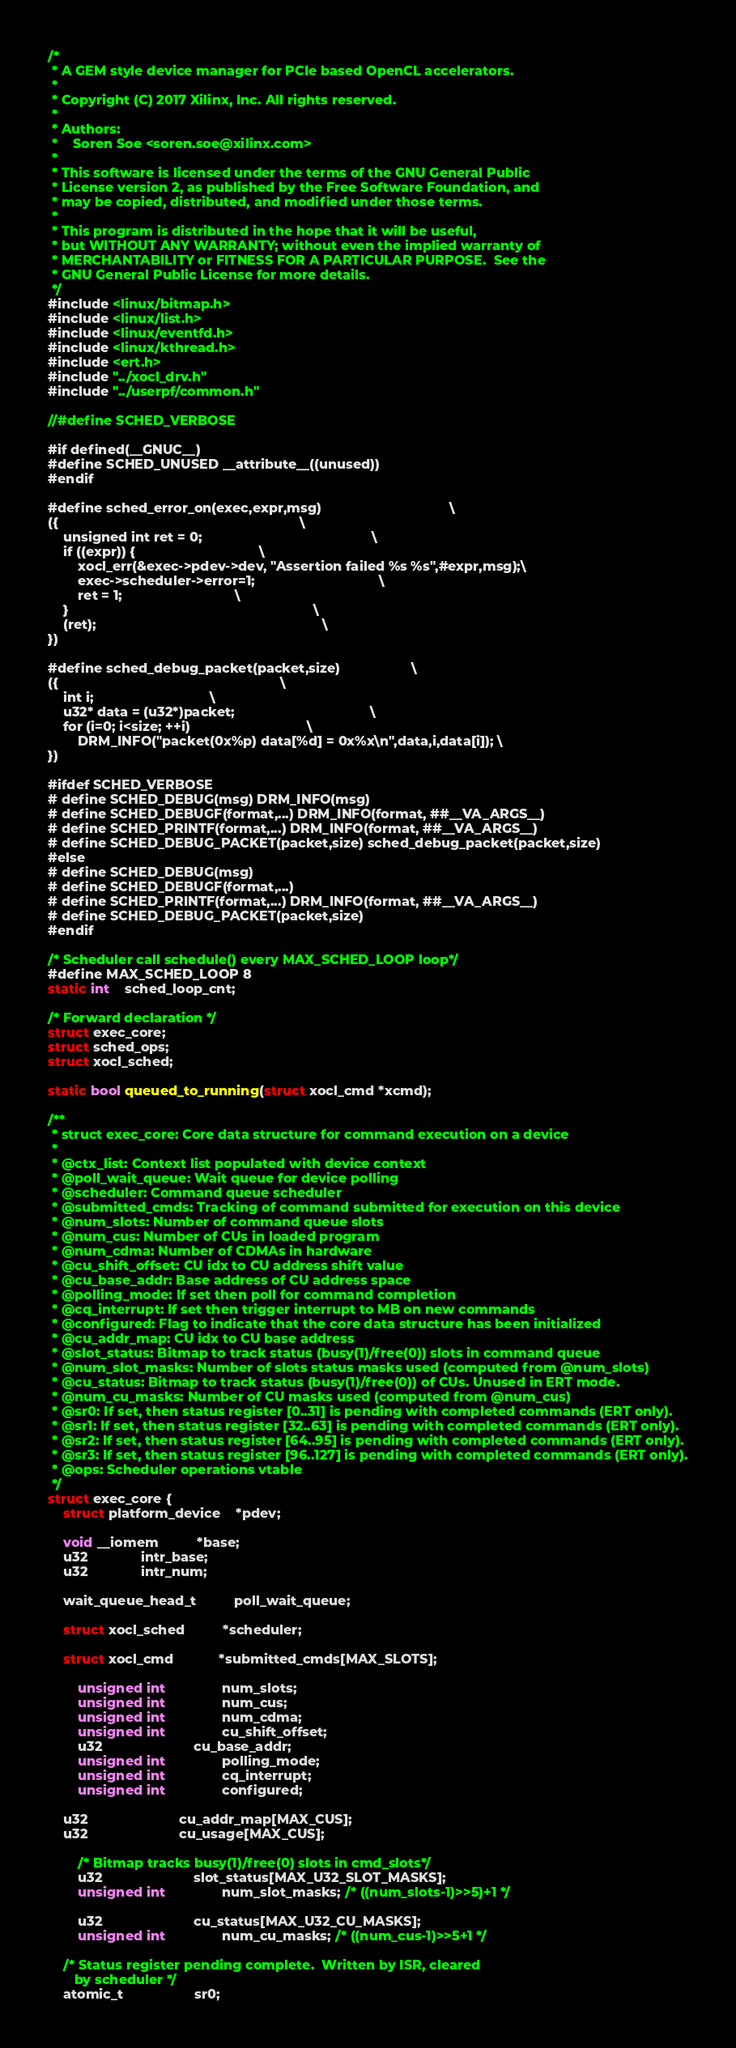Convert code to text. <code><loc_0><loc_0><loc_500><loc_500><_C_>/*
 * A GEM style device manager for PCIe based OpenCL accelerators.
 *
 * Copyright (C) 2017 Xilinx, Inc. All rights reserved.
 *
 * Authors:
 *    Soren Soe <soren.soe@xilinx.com>
 *
 * This software is licensed under the terms of the GNU General Public
 * License version 2, as published by the Free Software Foundation, and
 * may be copied, distributed, and modified under those terms.
 *
 * This program is distributed in the hope that it will be useful,
 * but WITHOUT ANY WARRANTY; without even the implied warranty of
 * MERCHANTABILITY or FITNESS FOR A PARTICULAR PURPOSE.  See the
 * GNU General Public License for more details.
 */
#include <linux/bitmap.h>
#include <linux/list.h>
#include <linux/eventfd.h>
#include <linux/kthread.h>
#include <ert.h>
#include "../xocl_drv.h"
#include "../userpf/common.h"

//#define SCHED_VERBOSE

#if defined(__GNUC__)
#define SCHED_UNUSED __attribute__((unused))
#endif

#define sched_error_on(exec,expr,msg)		                          \
({		                                                          \
	unsigned int ret = 0;                                             \
	if ((expr)) {						          \
		xocl_err(&exec->pdev->dev, "Assertion failed %s %s",#expr,msg);\
		exec->scheduler->error=1;                                 \
		ret = 1; 					          \
	}                                                                 \
	(ret);                                                            \
})

#define sched_debug_packet(packet,size)				     \
({		                                                     \
	int i;							     \
	u32* data = (u32*)packet;                                    \
	for (i=0; i<size; ++i)			    	             \
		DRM_INFO("packet(0x%p) data[%d] = 0x%x\n",data,i,data[i]); \
})

#ifdef SCHED_VERBOSE
# define SCHED_DEBUG(msg) DRM_INFO(msg)
# define SCHED_DEBUGF(format,...) DRM_INFO(format, ##__VA_ARGS__)
# define SCHED_PRINTF(format,...) DRM_INFO(format, ##__VA_ARGS__)
# define SCHED_DEBUG_PACKET(packet,size) sched_debug_packet(packet,size)
#else
# define SCHED_DEBUG(msg)
# define SCHED_DEBUGF(format,...)
# define SCHED_PRINTF(format,...) DRM_INFO(format, ##__VA_ARGS__)
# define SCHED_DEBUG_PACKET(packet,size)
#endif

/* Scheduler call schedule() every MAX_SCHED_LOOP loop*/
#define MAX_SCHED_LOOP 8
static int    sched_loop_cnt;

/* Forward declaration */
struct exec_core;
struct sched_ops;
struct xocl_sched;

static bool queued_to_running(struct xocl_cmd *xcmd);

/**
 * struct exec_core: Core data structure for command execution on a device
 *
 * @ctx_list: Context list populated with device context
 * @poll_wait_queue: Wait queue for device polling
 * @scheduler: Command queue scheduler
 * @submitted_cmds: Tracking of command submitted for execution on this device
 * @num_slots: Number of command queue slots
 * @num_cus: Number of CUs in loaded program
 * @num_cdma: Number of CDMAs in hardware
 * @cu_shift_offset: CU idx to CU address shift value
 * @cu_base_addr: Base address of CU address space
 * @polling_mode: If set then poll for command completion
 * @cq_interrupt: If set then trigger interrupt to MB on new commands
 * @configured: Flag to indicate that the core data structure has been initialized
 * @cu_addr_map: CU idx to CU base address
 * @slot_status: Bitmap to track status (busy(1)/free(0)) slots in command queue
 * @num_slot_masks: Number of slots status masks used (computed from @num_slots)
 * @cu_status: Bitmap to track status (busy(1)/free(0)) of CUs. Unused in ERT mode.
 * @num_cu_masks: Number of CU masks used (computed from @num_cus)
 * @sr0: If set, then status register [0..31] is pending with completed commands (ERT only).
 * @sr1: If set, then status register [32..63] is pending with completed commands (ERT only).
 * @sr2: If set, then status register [64..95] is pending with completed commands (ERT only).
 * @sr3: If set, then status register [96..127] is pending with completed commands (ERT only).
 * @ops: Scheduler operations vtable
 */
struct exec_core {
	struct platform_device    *pdev;

	void __iomem		  *base;
	u32			  intr_base;
	u32			  intr_num;

	wait_queue_head_t          poll_wait_queue;

	struct xocl_sched          *scheduler;

	struct xocl_cmd            *submitted_cmds[MAX_SLOTS];

        unsigned int               num_slots;
        unsigned int               num_cus;
        unsigned int               num_cdma;
        unsigned int               cu_shift_offset;
        u32                        cu_base_addr;
        unsigned int               polling_mode;
        unsigned int               cq_interrupt;
        unsigned int               configured;

	u32                        cu_addr_map[MAX_CUS];
	u32                        cu_usage[MAX_CUS];

        /* Bitmap tracks busy(1)/free(0) slots in cmd_slots*/
        u32                        slot_status[MAX_U32_SLOT_MASKS];
        unsigned int               num_slot_masks; /* ((num_slots-1)>>5)+1 */

        u32                        cu_status[MAX_U32_CU_MASKS];
        unsigned int               num_cu_masks; /* ((num_cus-1)>>5+1 */

	/* Status register pending complete.  Written by ISR, cleared
	   by scheduler */
	atomic_t                   sr0;</code> 